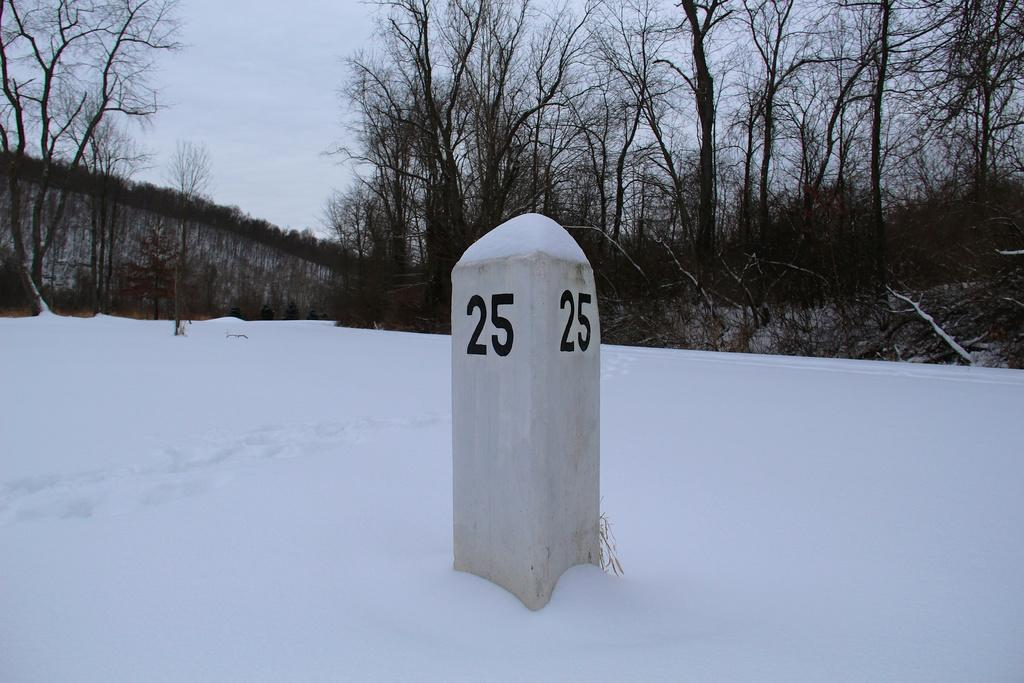What is the main object in the image? There is a pole in the image. What is written or displayed on the pole? There are numbers on the pole. What is the weather like in the image? There is snow visible in the image. What type of structure can be seen in the image? There is a wall in the image. What type of vegetation is present in the image? There are trees in the image. What is visible in the background of the image? The sky is visible in the background of the image. What type of lace can be seen on the pole in the image? There is no lace present on the pole in the image; it only has numbers displayed on it. 